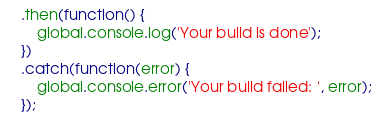<code> <loc_0><loc_0><loc_500><loc_500><_JavaScript_>	.then(function() {
		global.console.log('Your build is done');
	})
	.catch(function(error) {
		global.console.error('Your build failed: ', error);
	});
</code> 